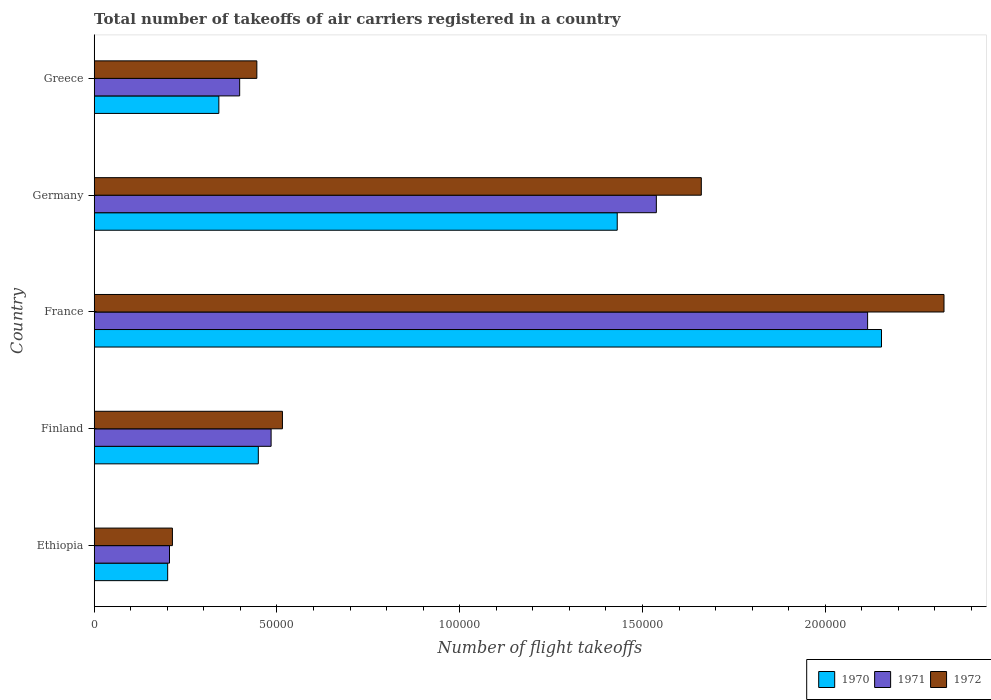How many different coloured bars are there?
Ensure brevity in your answer.  3. How many bars are there on the 5th tick from the bottom?
Keep it short and to the point. 3. What is the label of the 4th group of bars from the top?
Provide a short and direct response. Finland. In how many cases, is the number of bars for a given country not equal to the number of legend labels?
Your answer should be very brief. 0. What is the total number of flight takeoffs in 1970 in Greece?
Your answer should be compact. 3.41e+04. Across all countries, what is the maximum total number of flight takeoffs in 1970?
Ensure brevity in your answer.  2.15e+05. Across all countries, what is the minimum total number of flight takeoffs in 1970?
Your answer should be very brief. 2.01e+04. In which country was the total number of flight takeoffs in 1972 minimum?
Make the answer very short. Ethiopia. What is the total total number of flight takeoffs in 1970 in the graph?
Provide a short and direct response. 4.58e+05. What is the difference between the total number of flight takeoffs in 1971 in Ethiopia and that in Greece?
Keep it short and to the point. -1.92e+04. What is the difference between the total number of flight takeoffs in 1970 in Greece and the total number of flight takeoffs in 1972 in Germany?
Provide a succinct answer. -1.32e+05. What is the average total number of flight takeoffs in 1971 per country?
Your answer should be very brief. 9.48e+04. What is the difference between the total number of flight takeoffs in 1972 and total number of flight takeoffs in 1971 in Germany?
Your answer should be compact. 1.23e+04. What is the ratio of the total number of flight takeoffs in 1972 in Germany to that in Greece?
Ensure brevity in your answer.  3.73. Is the difference between the total number of flight takeoffs in 1972 in Finland and France greater than the difference between the total number of flight takeoffs in 1971 in Finland and France?
Provide a short and direct response. No. What is the difference between the highest and the second highest total number of flight takeoffs in 1970?
Provide a short and direct response. 7.23e+04. What is the difference between the highest and the lowest total number of flight takeoffs in 1970?
Offer a terse response. 1.95e+05. In how many countries, is the total number of flight takeoffs in 1970 greater than the average total number of flight takeoffs in 1970 taken over all countries?
Give a very brief answer. 2. Is the sum of the total number of flight takeoffs in 1971 in France and Germany greater than the maximum total number of flight takeoffs in 1970 across all countries?
Provide a succinct answer. Yes. What does the 3rd bar from the top in France represents?
Provide a succinct answer. 1970. How many bars are there?
Make the answer very short. 15. What is the difference between two consecutive major ticks on the X-axis?
Offer a very short reply. 5.00e+04. Does the graph contain any zero values?
Your answer should be very brief. No. Does the graph contain grids?
Give a very brief answer. No. Where does the legend appear in the graph?
Your response must be concise. Bottom right. How many legend labels are there?
Ensure brevity in your answer.  3. What is the title of the graph?
Provide a succinct answer. Total number of takeoffs of air carriers registered in a country. Does "1968" appear as one of the legend labels in the graph?
Your response must be concise. No. What is the label or title of the X-axis?
Provide a short and direct response. Number of flight takeoffs. What is the Number of flight takeoffs in 1970 in Ethiopia?
Make the answer very short. 2.01e+04. What is the Number of flight takeoffs of 1971 in Ethiopia?
Give a very brief answer. 2.06e+04. What is the Number of flight takeoffs in 1972 in Ethiopia?
Keep it short and to the point. 2.14e+04. What is the Number of flight takeoffs in 1970 in Finland?
Offer a very short reply. 4.49e+04. What is the Number of flight takeoffs of 1971 in Finland?
Your response must be concise. 4.84e+04. What is the Number of flight takeoffs of 1972 in Finland?
Provide a succinct answer. 5.15e+04. What is the Number of flight takeoffs of 1970 in France?
Your answer should be compact. 2.15e+05. What is the Number of flight takeoffs in 1971 in France?
Offer a terse response. 2.12e+05. What is the Number of flight takeoffs in 1972 in France?
Offer a very short reply. 2.32e+05. What is the Number of flight takeoffs of 1970 in Germany?
Your response must be concise. 1.43e+05. What is the Number of flight takeoffs in 1971 in Germany?
Offer a very short reply. 1.54e+05. What is the Number of flight takeoffs of 1972 in Germany?
Your answer should be compact. 1.66e+05. What is the Number of flight takeoffs of 1970 in Greece?
Your answer should be very brief. 3.41e+04. What is the Number of flight takeoffs of 1971 in Greece?
Provide a short and direct response. 3.98e+04. What is the Number of flight takeoffs in 1972 in Greece?
Your answer should be very brief. 4.45e+04. Across all countries, what is the maximum Number of flight takeoffs of 1970?
Give a very brief answer. 2.15e+05. Across all countries, what is the maximum Number of flight takeoffs of 1971?
Your response must be concise. 2.12e+05. Across all countries, what is the maximum Number of flight takeoffs in 1972?
Provide a short and direct response. 2.32e+05. Across all countries, what is the minimum Number of flight takeoffs in 1970?
Provide a short and direct response. 2.01e+04. Across all countries, what is the minimum Number of flight takeoffs in 1971?
Your response must be concise. 2.06e+04. Across all countries, what is the minimum Number of flight takeoffs of 1972?
Keep it short and to the point. 2.14e+04. What is the total Number of flight takeoffs in 1970 in the graph?
Your answer should be compact. 4.58e+05. What is the total Number of flight takeoffs in 1971 in the graph?
Your answer should be very brief. 4.74e+05. What is the total Number of flight takeoffs in 1972 in the graph?
Offer a very short reply. 5.16e+05. What is the difference between the Number of flight takeoffs of 1970 in Ethiopia and that in Finland?
Ensure brevity in your answer.  -2.48e+04. What is the difference between the Number of flight takeoffs in 1971 in Ethiopia and that in Finland?
Your answer should be compact. -2.78e+04. What is the difference between the Number of flight takeoffs of 1972 in Ethiopia and that in Finland?
Provide a short and direct response. -3.01e+04. What is the difference between the Number of flight takeoffs in 1970 in Ethiopia and that in France?
Your answer should be very brief. -1.95e+05. What is the difference between the Number of flight takeoffs of 1971 in Ethiopia and that in France?
Your answer should be compact. -1.91e+05. What is the difference between the Number of flight takeoffs in 1972 in Ethiopia and that in France?
Keep it short and to the point. -2.11e+05. What is the difference between the Number of flight takeoffs in 1970 in Ethiopia and that in Germany?
Your answer should be very brief. -1.23e+05. What is the difference between the Number of flight takeoffs in 1971 in Ethiopia and that in Germany?
Ensure brevity in your answer.  -1.33e+05. What is the difference between the Number of flight takeoffs of 1972 in Ethiopia and that in Germany?
Ensure brevity in your answer.  -1.45e+05. What is the difference between the Number of flight takeoffs of 1970 in Ethiopia and that in Greece?
Make the answer very short. -1.40e+04. What is the difference between the Number of flight takeoffs of 1971 in Ethiopia and that in Greece?
Offer a very short reply. -1.92e+04. What is the difference between the Number of flight takeoffs of 1972 in Ethiopia and that in Greece?
Make the answer very short. -2.31e+04. What is the difference between the Number of flight takeoffs of 1970 in Finland and that in France?
Your answer should be very brief. -1.70e+05. What is the difference between the Number of flight takeoffs in 1971 in Finland and that in France?
Your answer should be compact. -1.63e+05. What is the difference between the Number of flight takeoffs in 1972 in Finland and that in France?
Ensure brevity in your answer.  -1.81e+05. What is the difference between the Number of flight takeoffs in 1970 in Finland and that in Germany?
Give a very brief answer. -9.82e+04. What is the difference between the Number of flight takeoffs of 1971 in Finland and that in Germany?
Offer a terse response. -1.05e+05. What is the difference between the Number of flight takeoffs of 1972 in Finland and that in Germany?
Give a very brief answer. -1.15e+05. What is the difference between the Number of flight takeoffs in 1970 in Finland and that in Greece?
Provide a succinct answer. 1.08e+04. What is the difference between the Number of flight takeoffs of 1971 in Finland and that in Greece?
Provide a succinct answer. 8600. What is the difference between the Number of flight takeoffs in 1972 in Finland and that in Greece?
Your response must be concise. 7000. What is the difference between the Number of flight takeoffs of 1970 in France and that in Germany?
Give a very brief answer. 7.23e+04. What is the difference between the Number of flight takeoffs in 1971 in France and that in Germany?
Your answer should be very brief. 5.78e+04. What is the difference between the Number of flight takeoffs of 1972 in France and that in Germany?
Give a very brief answer. 6.64e+04. What is the difference between the Number of flight takeoffs in 1970 in France and that in Greece?
Provide a short and direct response. 1.81e+05. What is the difference between the Number of flight takeoffs in 1971 in France and that in Greece?
Keep it short and to the point. 1.72e+05. What is the difference between the Number of flight takeoffs of 1972 in France and that in Greece?
Provide a short and direct response. 1.88e+05. What is the difference between the Number of flight takeoffs of 1970 in Germany and that in Greece?
Your answer should be compact. 1.09e+05. What is the difference between the Number of flight takeoffs of 1971 in Germany and that in Greece?
Provide a short and direct response. 1.14e+05. What is the difference between the Number of flight takeoffs of 1972 in Germany and that in Greece?
Ensure brevity in your answer.  1.22e+05. What is the difference between the Number of flight takeoffs of 1970 in Ethiopia and the Number of flight takeoffs of 1971 in Finland?
Ensure brevity in your answer.  -2.83e+04. What is the difference between the Number of flight takeoffs of 1970 in Ethiopia and the Number of flight takeoffs of 1972 in Finland?
Give a very brief answer. -3.14e+04. What is the difference between the Number of flight takeoffs in 1971 in Ethiopia and the Number of flight takeoffs in 1972 in Finland?
Offer a very short reply. -3.09e+04. What is the difference between the Number of flight takeoffs in 1970 in Ethiopia and the Number of flight takeoffs in 1971 in France?
Provide a succinct answer. -1.92e+05. What is the difference between the Number of flight takeoffs in 1970 in Ethiopia and the Number of flight takeoffs in 1972 in France?
Offer a terse response. -2.12e+05. What is the difference between the Number of flight takeoffs of 1971 in Ethiopia and the Number of flight takeoffs of 1972 in France?
Your response must be concise. -2.12e+05. What is the difference between the Number of flight takeoffs of 1970 in Ethiopia and the Number of flight takeoffs of 1971 in Germany?
Keep it short and to the point. -1.34e+05. What is the difference between the Number of flight takeoffs in 1970 in Ethiopia and the Number of flight takeoffs in 1972 in Germany?
Give a very brief answer. -1.46e+05. What is the difference between the Number of flight takeoffs of 1971 in Ethiopia and the Number of flight takeoffs of 1972 in Germany?
Ensure brevity in your answer.  -1.46e+05. What is the difference between the Number of flight takeoffs in 1970 in Ethiopia and the Number of flight takeoffs in 1971 in Greece?
Your answer should be very brief. -1.97e+04. What is the difference between the Number of flight takeoffs of 1970 in Ethiopia and the Number of flight takeoffs of 1972 in Greece?
Your answer should be very brief. -2.44e+04. What is the difference between the Number of flight takeoffs in 1971 in Ethiopia and the Number of flight takeoffs in 1972 in Greece?
Ensure brevity in your answer.  -2.39e+04. What is the difference between the Number of flight takeoffs in 1970 in Finland and the Number of flight takeoffs in 1971 in France?
Your response must be concise. -1.67e+05. What is the difference between the Number of flight takeoffs of 1970 in Finland and the Number of flight takeoffs of 1972 in France?
Ensure brevity in your answer.  -1.88e+05. What is the difference between the Number of flight takeoffs of 1971 in Finland and the Number of flight takeoffs of 1972 in France?
Provide a short and direct response. -1.84e+05. What is the difference between the Number of flight takeoffs of 1970 in Finland and the Number of flight takeoffs of 1971 in Germany?
Provide a succinct answer. -1.09e+05. What is the difference between the Number of flight takeoffs of 1970 in Finland and the Number of flight takeoffs of 1972 in Germany?
Your answer should be compact. -1.21e+05. What is the difference between the Number of flight takeoffs in 1971 in Finland and the Number of flight takeoffs in 1972 in Germany?
Keep it short and to the point. -1.18e+05. What is the difference between the Number of flight takeoffs in 1970 in Finland and the Number of flight takeoffs in 1971 in Greece?
Offer a very short reply. 5100. What is the difference between the Number of flight takeoffs in 1971 in Finland and the Number of flight takeoffs in 1972 in Greece?
Your response must be concise. 3900. What is the difference between the Number of flight takeoffs in 1970 in France and the Number of flight takeoffs in 1971 in Germany?
Provide a short and direct response. 6.16e+04. What is the difference between the Number of flight takeoffs in 1970 in France and the Number of flight takeoffs in 1972 in Germany?
Make the answer very short. 4.93e+04. What is the difference between the Number of flight takeoffs of 1971 in France and the Number of flight takeoffs of 1972 in Germany?
Make the answer very short. 4.55e+04. What is the difference between the Number of flight takeoffs in 1970 in France and the Number of flight takeoffs in 1971 in Greece?
Offer a terse response. 1.76e+05. What is the difference between the Number of flight takeoffs of 1970 in France and the Number of flight takeoffs of 1972 in Greece?
Your answer should be compact. 1.71e+05. What is the difference between the Number of flight takeoffs in 1971 in France and the Number of flight takeoffs in 1972 in Greece?
Make the answer very short. 1.67e+05. What is the difference between the Number of flight takeoffs in 1970 in Germany and the Number of flight takeoffs in 1971 in Greece?
Give a very brief answer. 1.03e+05. What is the difference between the Number of flight takeoffs in 1970 in Germany and the Number of flight takeoffs in 1972 in Greece?
Your answer should be very brief. 9.86e+04. What is the difference between the Number of flight takeoffs of 1971 in Germany and the Number of flight takeoffs of 1972 in Greece?
Keep it short and to the point. 1.09e+05. What is the average Number of flight takeoffs of 1970 per country?
Give a very brief answer. 9.15e+04. What is the average Number of flight takeoffs in 1971 per country?
Your answer should be compact. 9.48e+04. What is the average Number of flight takeoffs in 1972 per country?
Give a very brief answer. 1.03e+05. What is the difference between the Number of flight takeoffs in 1970 and Number of flight takeoffs in 1971 in Ethiopia?
Provide a succinct answer. -500. What is the difference between the Number of flight takeoffs of 1970 and Number of flight takeoffs of 1972 in Ethiopia?
Your response must be concise. -1300. What is the difference between the Number of flight takeoffs of 1971 and Number of flight takeoffs of 1972 in Ethiopia?
Provide a short and direct response. -800. What is the difference between the Number of flight takeoffs in 1970 and Number of flight takeoffs in 1971 in Finland?
Make the answer very short. -3500. What is the difference between the Number of flight takeoffs of 1970 and Number of flight takeoffs of 1972 in Finland?
Keep it short and to the point. -6600. What is the difference between the Number of flight takeoffs in 1971 and Number of flight takeoffs in 1972 in Finland?
Offer a terse response. -3100. What is the difference between the Number of flight takeoffs of 1970 and Number of flight takeoffs of 1971 in France?
Keep it short and to the point. 3800. What is the difference between the Number of flight takeoffs of 1970 and Number of flight takeoffs of 1972 in France?
Your response must be concise. -1.71e+04. What is the difference between the Number of flight takeoffs in 1971 and Number of flight takeoffs in 1972 in France?
Your answer should be very brief. -2.09e+04. What is the difference between the Number of flight takeoffs in 1970 and Number of flight takeoffs in 1971 in Germany?
Your response must be concise. -1.07e+04. What is the difference between the Number of flight takeoffs in 1970 and Number of flight takeoffs in 1972 in Germany?
Make the answer very short. -2.30e+04. What is the difference between the Number of flight takeoffs of 1971 and Number of flight takeoffs of 1972 in Germany?
Offer a very short reply. -1.23e+04. What is the difference between the Number of flight takeoffs in 1970 and Number of flight takeoffs in 1971 in Greece?
Your answer should be very brief. -5700. What is the difference between the Number of flight takeoffs of 1970 and Number of flight takeoffs of 1972 in Greece?
Your answer should be very brief. -1.04e+04. What is the difference between the Number of flight takeoffs in 1971 and Number of flight takeoffs in 1972 in Greece?
Your answer should be very brief. -4700. What is the ratio of the Number of flight takeoffs of 1970 in Ethiopia to that in Finland?
Provide a short and direct response. 0.45. What is the ratio of the Number of flight takeoffs of 1971 in Ethiopia to that in Finland?
Make the answer very short. 0.43. What is the ratio of the Number of flight takeoffs of 1972 in Ethiopia to that in Finland?
Your response must be concise. 0.42. What is the ratio of the Number of flight takeoffs in 1970 in Ethiopia to that in France?
Ensure brevity in your answer.  0.09. What is the ratio of the Number of flight takeoffs in 1971 in Ethiopia to that in France?
Provide a short and direct response. 0.1. What is the ratio of the Number of flight takeoffs of 1972 in Ethiopia to that in France?
Offer a terse response. 0.09. What is the ratio of the Number of flight takeoffs of 1970 in Ethiopia to that in Germany?
Offer a terse response. 0.14. What is the ratio of the Number of flight takeoffs in 1971 in Ethiopia to that in Germany?
Provide a short and direct response. 0.13. What is the ratio of the Number of flight takeoffs of 1972 in Ethiopia to that in Germany?
Keep it short and to the point. 0.13. What is the ratio of the Number of flight takeoffs in 1970 in Ethiopia to that in Greece?
Your answer should be compact. 0.59. What is the ratio of the Number of flight takeoffs of 1971 in Ethiopia to that in Greece?
Give a very brief answer. 0.52. What is the ratio of the Number of flight takeoffs of 1972 in Ethiopia to that in Greece?
Keep it short and to the point. 0.48. What is the ratio of the Number of flight takeoffs of 1970 in Finland to that in France?
Ensure brevity in your answer.  0.21. What is the ratio of the Number of flight takeoffs of 1971 in Finland to that in France?
Your response must be concise. 0.23. What is the ratio of the Number of flight takeoffs of 1972 in Finland to that in France?
Offer a very short reply. 0.22. What is the ratio of the Number of flight takeoffs in 1970 in Finland to that in Germany?
Provide a short and direct response. 0.31. What is the ratio of the Number of flight takeoffs of 1971 in Finland to that in Germany?
Offer a very short reply. 0.31. What is the ratio of the Number of flight takeoffs of 1972 in Finland to that in Germany?
Your answer should be very brief. 0.31. What is the ratio of the Number of flight takeoffs of 1970 in Finland to that in Greece?
Ensure brevity in your answer.  1.32. What is the ratio of the Number of flight takeoffs in 1971 in Finland to that in Greece?
Offer a terse response. 1.22. What is the ratio of the Number of flight takeoffs in 1972 in Finland to that in Greece?
Your answer should be compact. 1.16. What is the ratio of the Number of flight takeoffs of 1970 in France to that in Germany?
Provide a succinct answer. 1.51. What is the ratio of the Number of flight takeoffs of 1971 in France to that in Germany?
Provide a succinct answer. 1.38. What is the ratio of the Number of flight takeoffs of 1972 in France to that in Germany?
Your response must be concise. 1.4. What is the ratio of the Number of flight takeoffs of 1970 in France to that in Greece?
Give a very brief answer. 6.32. What is the ratio of the Number of flight takeoffs of 1971 in France to that in Greece?
Your answer should be very brief. 5.32. What is the ratio of the Number of flight takeoffs in 1972 in France to that in Greece?
Make the answer very short. 5.22. What is the ratio of the Number of flight takeoffs of 1970 in Germany to that in Greece?
Keep it short and to the point. 4.2. What is the ratio of the Number of flight takeoffs of 1971 in Germany to that in Greece?
Keep it short and to the point. 3.86. What is the ratio of the Number of flight takeoffs of 1972 in Germany to that in Greece?
Give a very brief answer. 3.73. What is the difference between the highest and the second highest Number of flight takeoffs in 1970?
Give a very brief answer. 7.23e+04. What is the difference between the highest and the second highest Number of flight takeoffs of 1971?
Ensure brevity in your answer.  5.78e+04. What is the difference between the highest and the second highest Number of flight takeoffs in 1972?
Your response must be concise. 6.64e+04. What is the difference between the highest and the lowest Number of flight takeoffs of 1970?
Your answer should be very brief. 1.95e+05. What is the difference between the highest and the lowest Number of flight takeoffs of 1971?
Make the answer very short. 1.91e+05. What is the difference between the highest and the lowest Number of flight takeoffs of 1972?
Keep it short and to the point. 2.11e+05. 